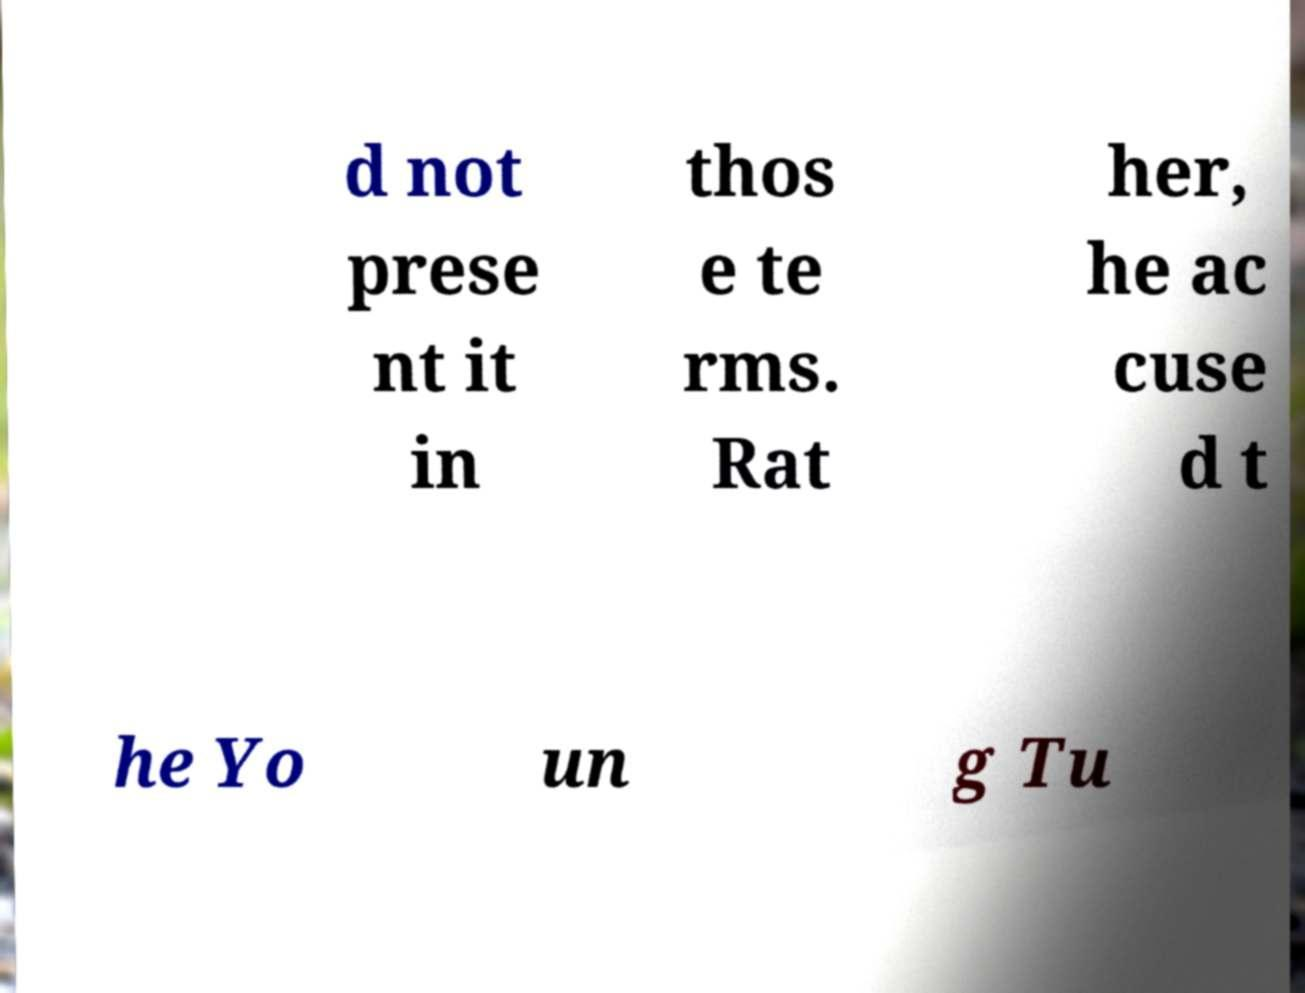What messages or text are displayed in this image? I need them in a readable, typed format. d not prese nt it in thos e te rms. Rat her, he ac cuse d t he Yo un g Tu 